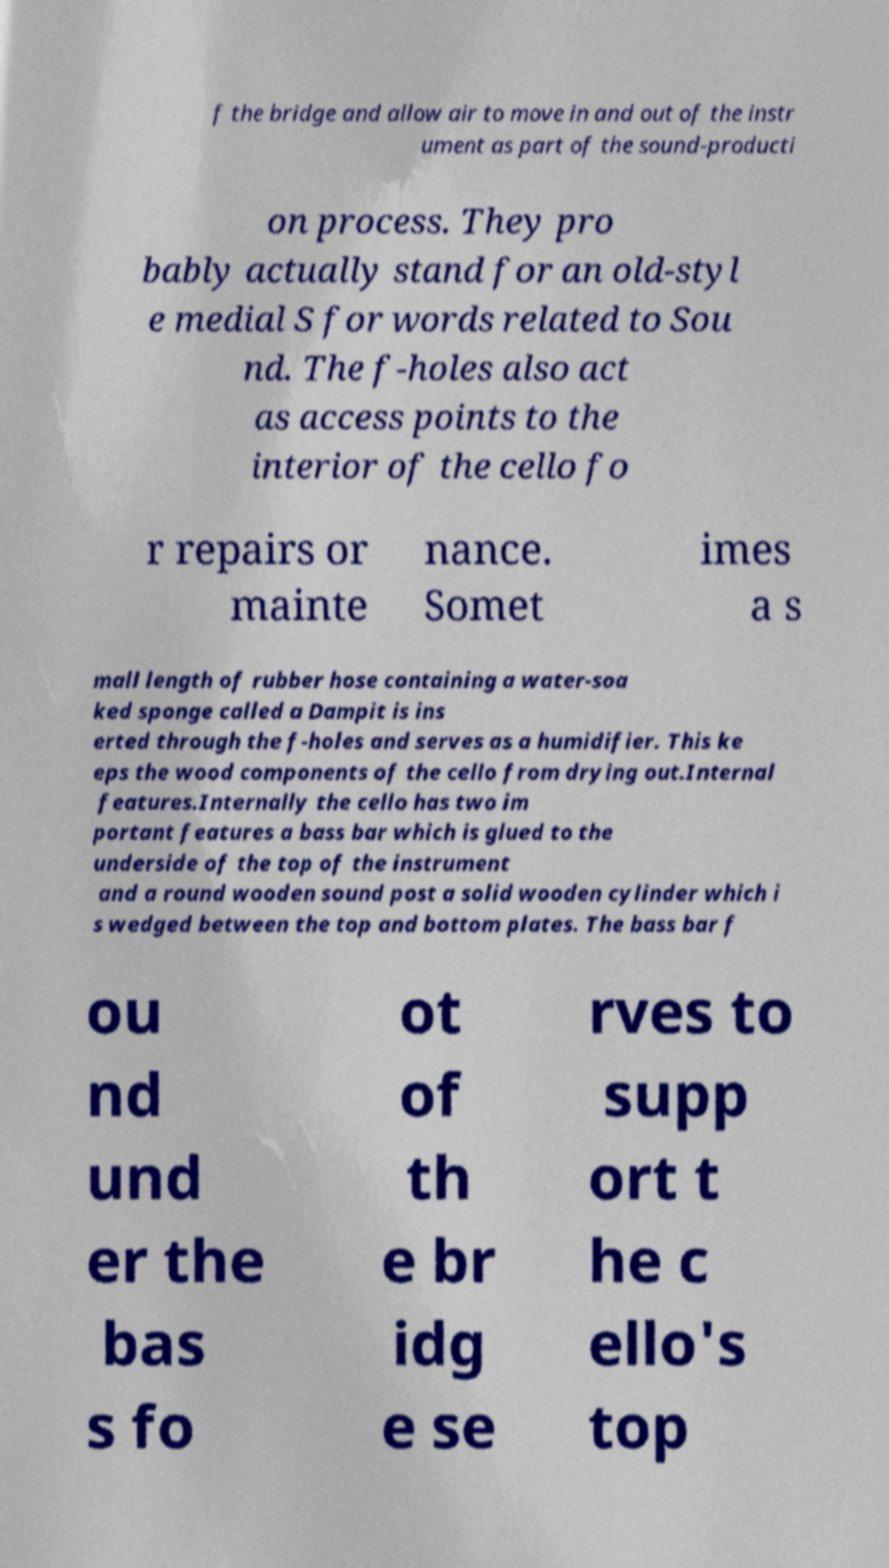Please read and relay the text visible in this image. What does it say? f the bridge and allow air to move in and out of the instr ument as part of the sound-producti on process. They pro bably actually stand for an old-styl e medial S for words related to Sou nd. The f-holes also act as access points to the interior of the cello fo r repairs or mainte nance. Somet imes a s mall length of rubber hose containing a water-soa ked sponge called a Dampit is ins erted through the f-holes and serves as a humidifier. This ke eps the wood components of the cello from drying out.Internal features.Internally the cello has two im portant features a bass bar which is glued to the underside of the top of the instrument and a round wooden sound post a solid wooden cylinder which i s wedged between the top and bottom plates. The bass bar f ou nd und er the bas s fo ot of th e br idg e se rves to supp ort t he c ello's top 